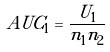<formula> <loc_0><loc_0><loc_500><loc_500>A U C _ { 1 } = \frac { U _ { 1 } } { n _ { 1 } n _ { 2 } }</formula> 